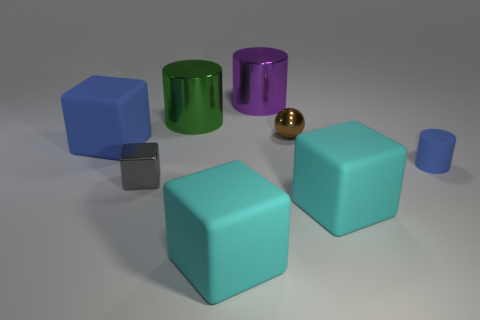Subtract all gray shiny cubes. How many cubes are left? 3 Add 1 blue cylinders. How many objects exist? 9 Subtract all gray blocks. How many blocks are left? 3 Subtract all green cylinders. How many blue cubes are left? 1 Subtract all tiny gray metallic cubes. Subtract all tiny gray objects. How many objects are left? 6 Add 4 big cyan cubes. How many big cyan cubes are left? 6 Add 8 big cyan matte spheres. How many big cyan matte spheres exist? 8 Subtract 0 cyan spheres. How many objects are left? 8 Subtract all cylinders. How many objects are left? 5 Subtract all green blocks. Subtract all green spheres. How many blocks are left? 4 